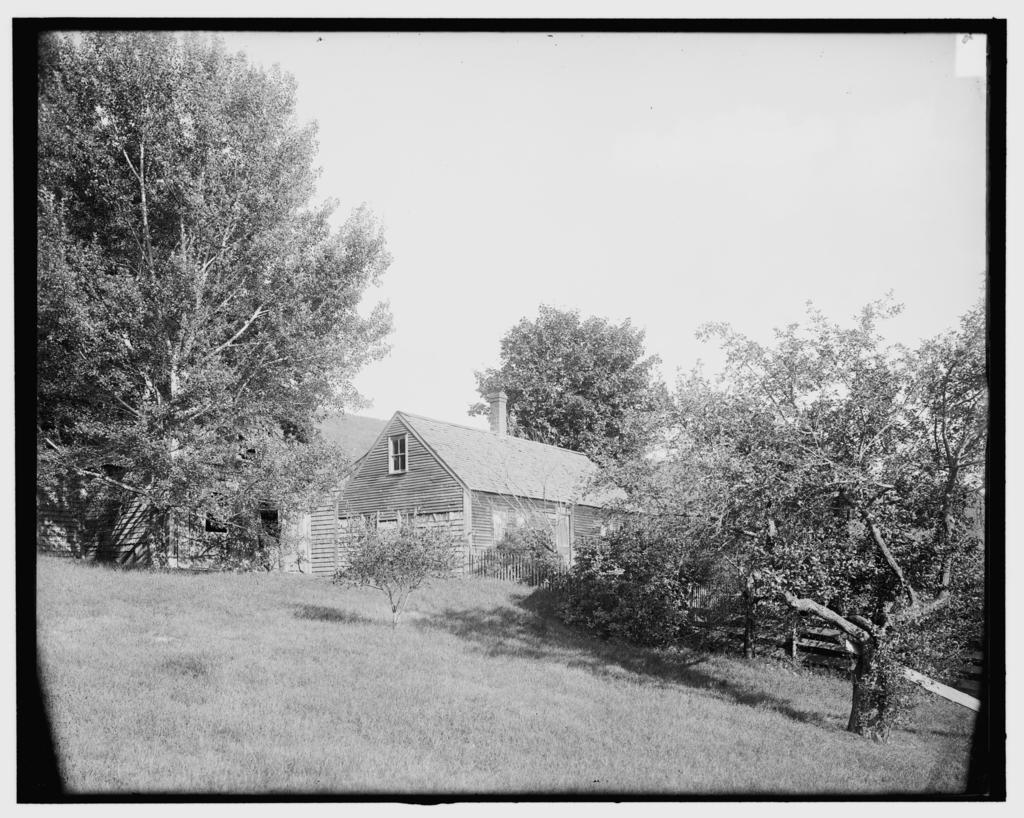Describe this image in one or two sentences. In this image in the background there are trees and there is a house and there is grass in the center. 